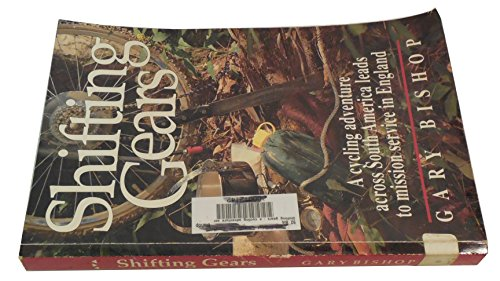Is this book related to Travel? Yes, this book is intrinsically related to travel, exploring various landscapes and experiences within South America through cycling adventures. 